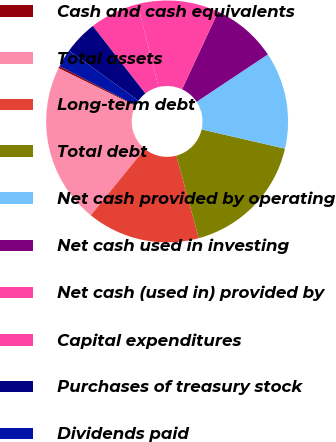Convert chart. <chart><loc_0><loc_0><loc_500><loc_500><pie_chart><fcel>Cash and cash equivalents<fcel>Total assets<fcel>Long-term debt<fcel>Total debt<fcel>Net cash provided by operating<fcel>Net cash used in investing<fcel>Net cash (used in) provided by<fcel>Capital expenditures<fcel>Purchases of treasury stock<fcel>Dividends paid<nl><fcel>0.29%<fcel>21.4%<fcel>15.07%<fcel>17.18%<fcel>12.96%<fcel>8.73%<fcel>10.84%<fcel>6.62%<fcel>4.51%<fcel>2.4%<nl></chart> 